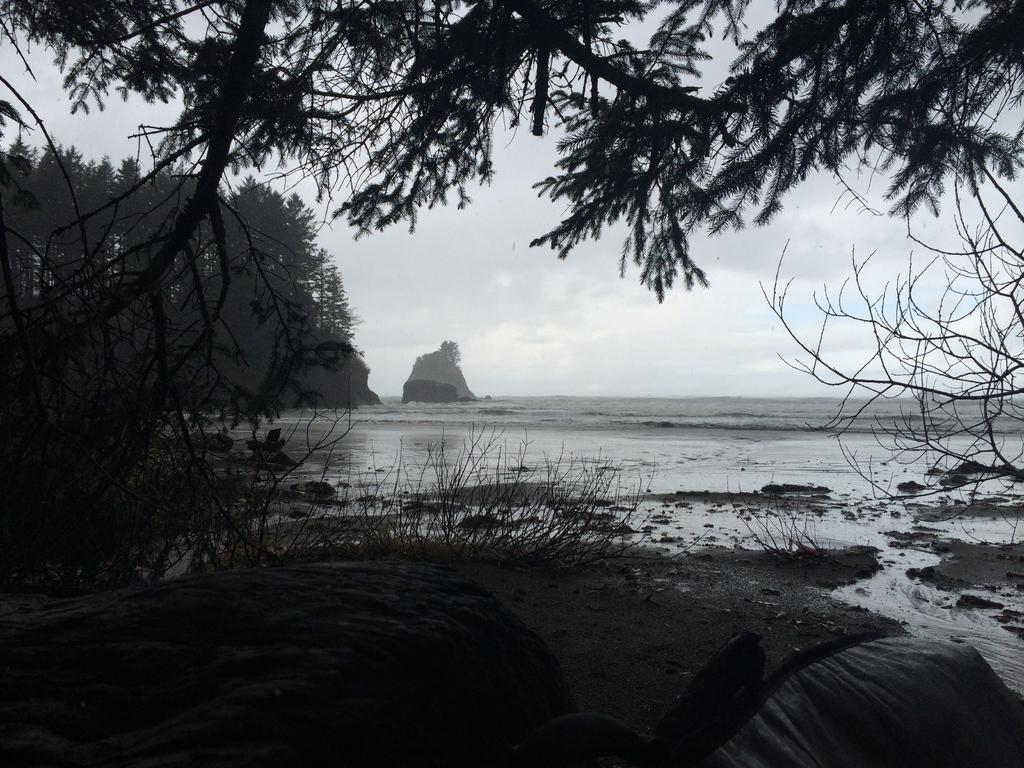Describe this image in one or two sentences. In this image there is sky, there is mountain, there is sea, there are treeś, there are plantś. 